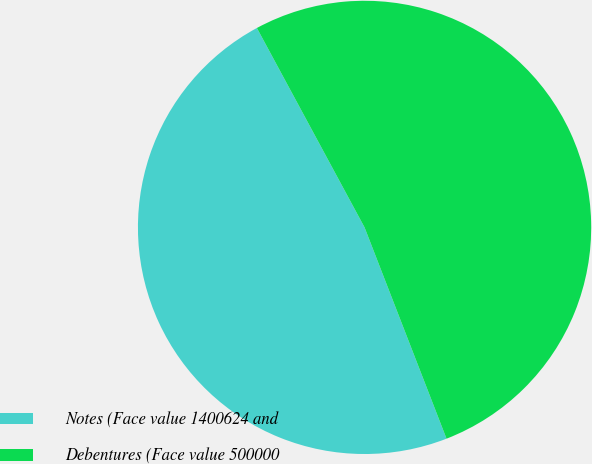<chart> <loc_0><loc_0><loc_500><loc_500><pie_chart><fcel>Notes (Face value 1400624 and<fcel>Debentures (Face value 500000<nl><fcel>48.01%<fcel>51.99%<nl></chart> 